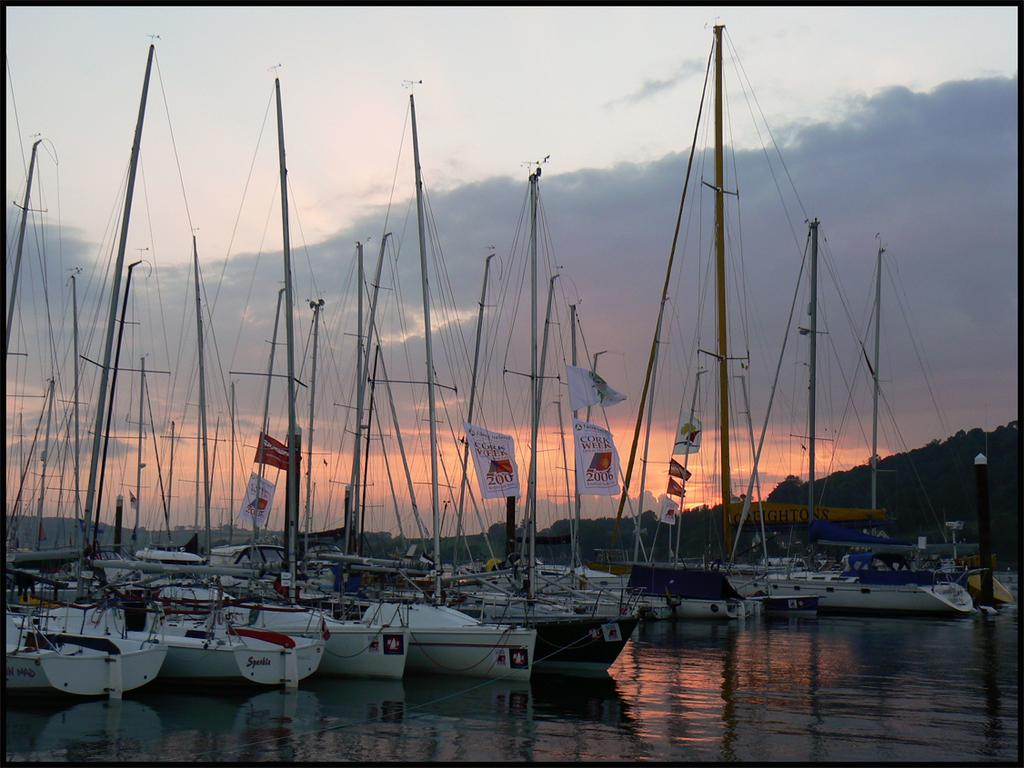<image>
Write a terse but informative summary of the picture. Many boats in the water with a flag that says Cork Week. 